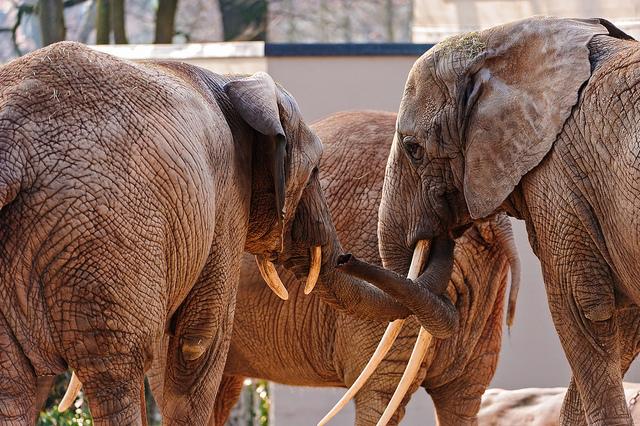Are these Indian elephants?
Short answer required. Yes. What part of the elephants are touching one another?
Short answer required. Trunks. What color are the animals?
Give a very brief answer. Gray. Are they old?
Keep it brief. Yes. 